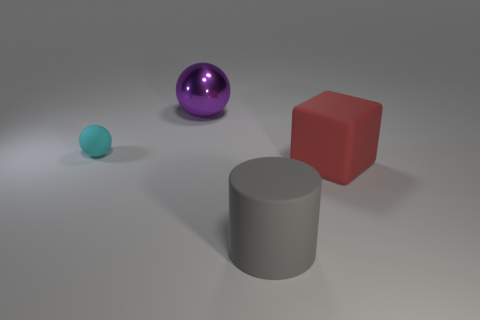Add 4 green cubes. How many objects exist? 8 Subtract 1 cylinders. How many cylinders are left? 0 Subtract all purple balls. How many balls are left? 1 Subtract all cylinders. How many objects are left? 3 Subtract 0 blue cubes. How many objects are left? 4 Subtract all yellow spheres. Subtract all blue cylinders. How many spheres are left? 2 Subtract all red blocks. How many blue spheres are left? 0 Subtract all small cyan balls. Subtract all matte cylinders. How many objects are left? 2 Add 3 small cyan rubber balls. How many small cyan rubber balls are left? 4 Add 2 big shiny balls. How many big shiny balls exist? 3 